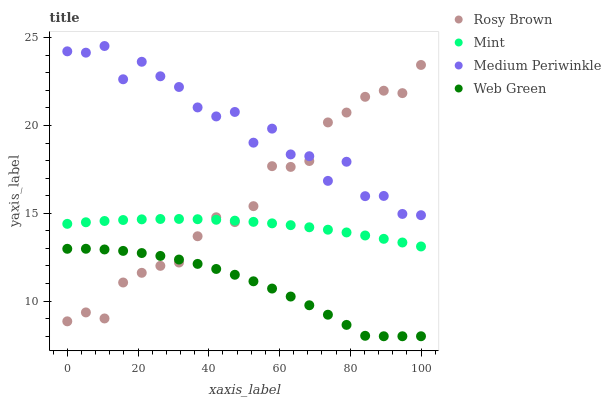Does Web Green have the minimum area under the curve?
Answer yes or no. Yes. Does Medium Periwinkle have the maximum area under the curve?
Answer yes or no. Yes. Does Rosy Brown have the minimum area under the curve?
Answer yes or no. No. Does Rosy Brown have the maximum area under the curve?
Answer yes or no. No. Is Mint the smoothest?
Answer yes or no. Yes. Is Medium Periwinkle the roughest?
Answer yes or no. Yes. Is Rosy Brown the smoothest?
Answer yes or no. No. Is Rosy Brown the roughest?
Answer yes or no. No. Does Web Green have the lowest value?
Answer yes or no. Yes. Does Rosy Brown have the lowest value?
Answer yes or no. No. Does Medium Periwinkle have the highest value?
Answer yes or no. Yes. Does Rosy Brown have the highest value?
Answer yes or no. No. Is Web Green less than Mint?
Answer yes or no. Yes. Is Mint greater than Web Green?
Answer yes or no. Yes. Does Mint intersect Rosy Brown?
Answer yes or no. Yes. Is Mint less than Rosy Brown?
Answer yes or no. No. Is Mint greater than Rosy Brown?
Answer yes or no. No. Does Web Green intersect Mint?
Answer yes or no. No. 